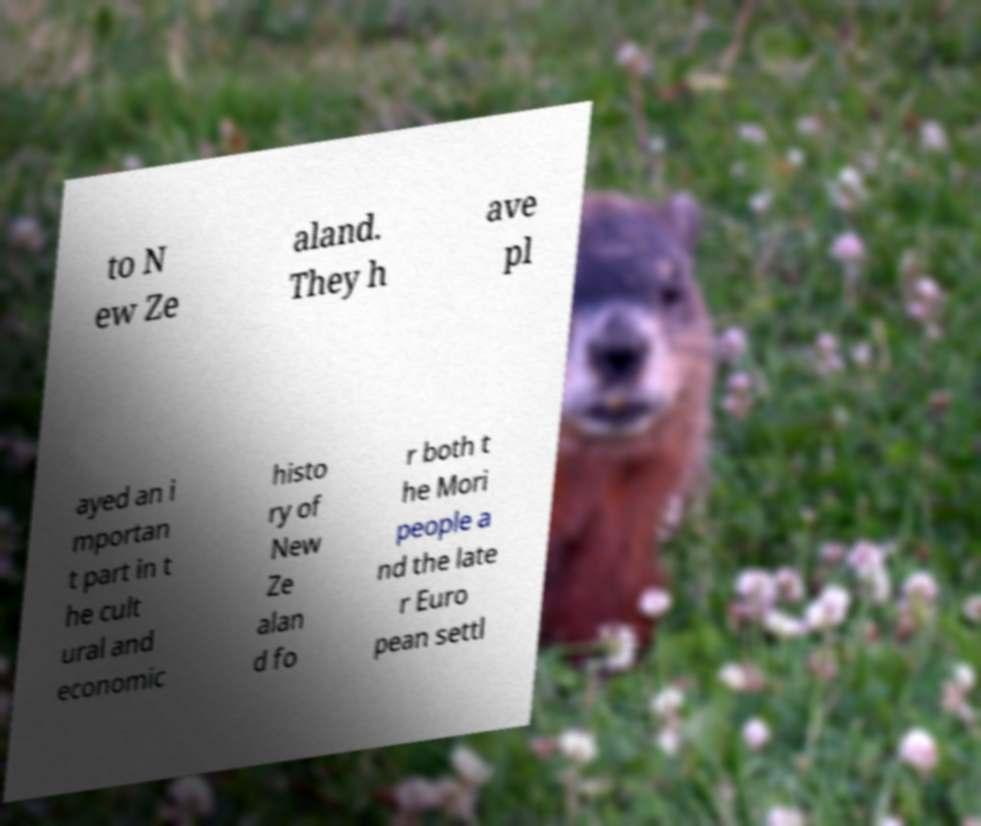Can you accurately transcribe the text from the provided image for me? to N ew Ze aland. They h ave pl ayed an i mportan t part in t he cult ural and economic histo ry of New Ze alan d fo r both t he Mori people a nd the late r Euro pean settl 